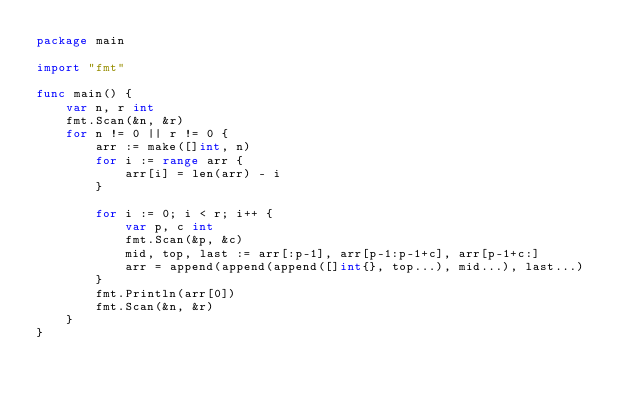Convert code to text. <code><loc_0><loc_0><loc_500><loc_500><_Go_>package main

import "fmt"

func main() {
	var n, r int
	fmt.Scan(&n, &r)
	for n != 0 || r != 0 {
		arr := make([]int, n)
		for i := range arr {
			arr[i] = len(arr) - i
		}

		for i := 0; i < r; i++ {
			var p, c int
			fmt.Scan(&p, &c)
			mid, top, last := arr[:p-1], arr[p-1:p-1+c], arr[p-1+c:]
			arr = append(append(append([]int{}, top...), mid...), last...)
		}
		fmt.Println(arr[0])
		fmt.Scan(&n, &r)
	}
}

</code> 